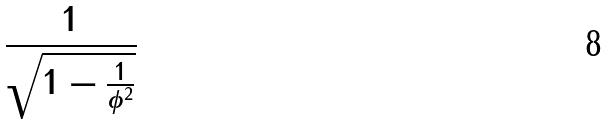Convert formula to latex. <formula><loc_0><loc_0><loc_500><loc_500>\frac { 1 } { \sqrt { 1 - \frac { 1 } { \phi ^ { 2 } } } }</formula> 